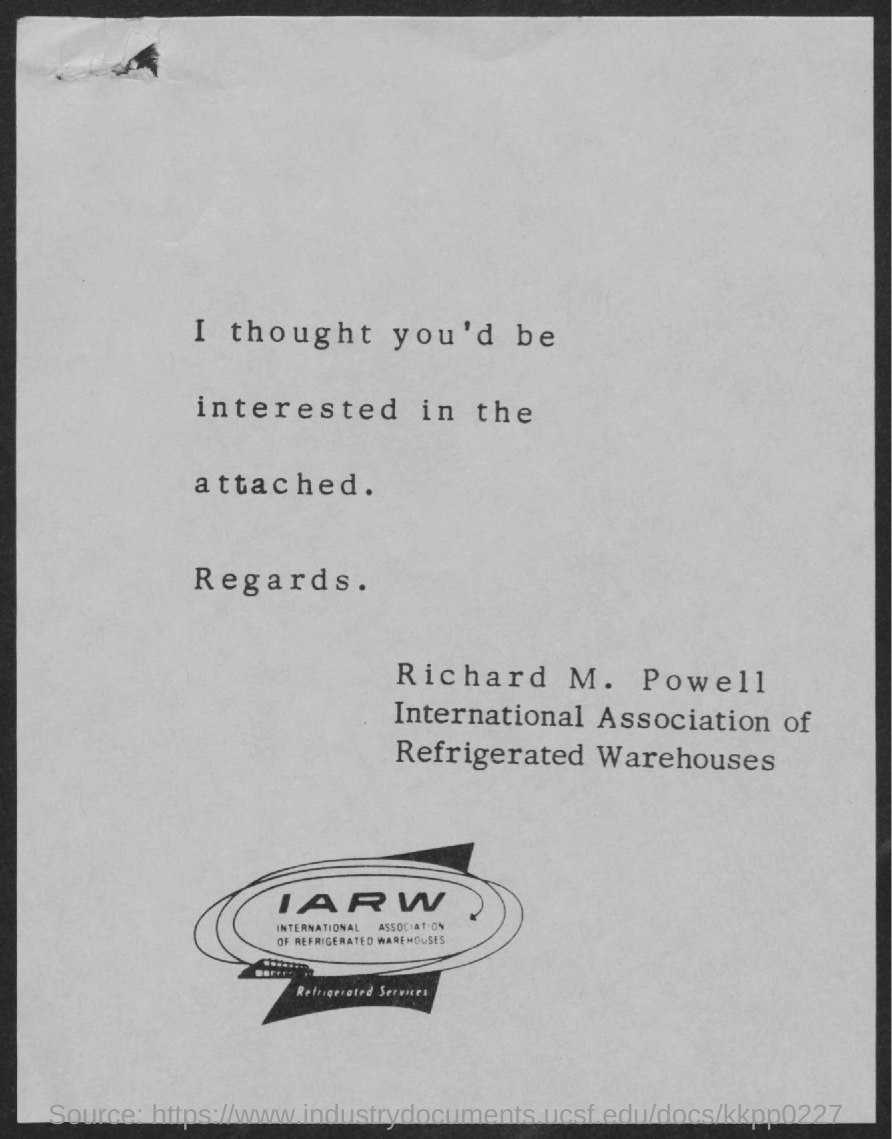What is the full form of iarw?
Offer a very short reply. International Association of Refrigerated Warehouses. 